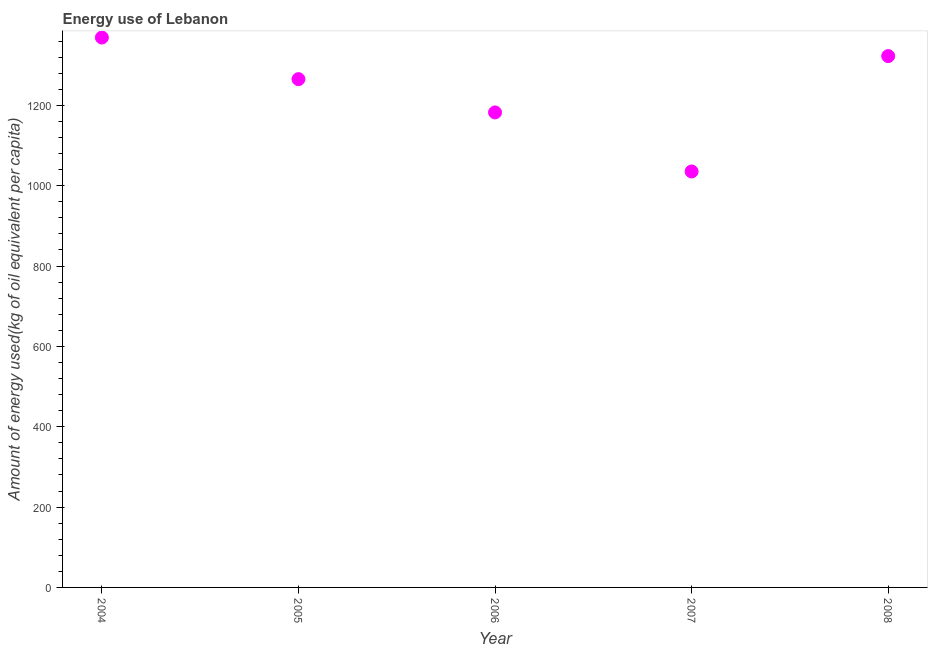What is the amount of energy used in 2007?
Give a very brief answer. 1035.39. Across all years, what is the maximum amount of energy used?
Keep it short and to the point. 1368.81. Across all years, what is the minimum amount of energy used?
Keep it short and to the point. 1035.39. What is the sum of the amount of energy used?
Ensure brevity in your answer.  6174.39. What is the difference between the amount of energy used in 2004 and 2005?
Provide a succinct answer. 103.59. What is the average amount of energy used per year?
Your answer should be very brief. 1234.88. What is the median amount of energy used?
Ensure brevity in your answer.  1265.23. What is the ratio of the amount of energy used in 2007 to that in 2008?
Your response must be concise. 0.78. What is the difference between the highest and the second highest amount of energy used?
Make the answer very short. 46.21. What is the difference between the highest and the lowest amount of energy used?
Provide a succinct answer. 333.42. In how many years, is the amount of energy used greater than the average amount of energy used taken over all years?
Ensure brevity in your answer.  3. How many dotlines are there?
Ensure brevity in your answer.  1. How many years are there in the graph?
Keep it short and to the point. 5. Are the values on the major ticks of Y-axis written in scientific E-notation?
Keep it short and to the point. No. Does the graph contain grids?
Provide a short and direct response. No. What is the title of the graph?
Your answer should be very brief. Energy use of Lebanon. What is the label or title of the Y-axis?
Provide a short and direct response. Amount of energy used(kg of oil equivalent per capita). What is the Amount of energy used(kg of oil equivalent per capita) in 2004?
Keep it short and to the point. 1368.81. What is the Amount of energy used(kg of oil equivalent per capita) in 2005?
Offer a very short reply. 1265.23. What is the Amount of energy used(kg of oil equivalent per capita) in 2006?
Offer a terse response. 1182.36. What is the Amount of energy used(kg of oil equivalent per capita) in 2007?
Ensure brevity in your answer.  1035.39. What is the Amount of energy used(kg of oil equivalent per capita) in 2008?
Your answer should be very brief. 1322.6. What is the difference between the Amount of energy used(kg of oil equivalent per capita) in 2004 and 2005?
Offer a terse response. 103.59. What is the difference between the Amount of energy used(kg of oil equivalent per capita) in 2004 and 2006?
Keep it short and to the point. 186.45. What is the difference between the Amount of energy used(kg of oil equivalent per capita) in 2004 and 2007?
Offer a very short reply. 333.42. What is the difference between the Amount of energy used(kg of oil equivalent per capita) in 2004 and 2008?
Offer a terse response. 46.21. What is the difference between the Amount of energy used(kg of oil equivalent per capita) in 2005 and 2006?
Provide a succinct answer. 82.86. What is the difference between the Amount of energy used(kg of oil equivalent per capita) in 2005 and 2007?
Offer a very short reply. 229.83. What is the difference between the Amount of energy used(kg of oil equivalent per capita) in 2005 and 2008?
Offer a very short reply. -57.38. What is the difference between the Amount of energy used(kg of oil equivalent per capita) in 2006 and 2007?
Your answer should be compact. 146.97. What is the difference between the Amount of energy used(kg of oil equivalent per capita) in 2006 and 2008?
Keep it short and to the point. -140.24. What is the difference between the Amount of energy used(kg of oil equivalent per capita) in 2007 and 2008?
Offer a terse response. -287.21. What is the ratio of the Amount of energy used(kg of oil equivalent per capita) in 2004 to that in 2005?
Give a very brief answer. 1.08. What is the ratio of the Amount of energy used(kg of oil equivalent per capita) in 2004 to that in 2006?
Give a very brief answer. 1.16. What is the ratio of the Amount of energy used(kg of oil equivalent per capita) in 2004 to that in 2007?
Offer a terse response. 1.32. What is the ratio of the Amount of energy used(kg of oil equivalent per capita) in 2004 to that in 2008?
Keep it short and to the point. 1.03. What is the ratio of the Amount of energy used(kg of oil equivalent per capita) in 2005 to that in 2006?
Offer a terse response. 1.07. What is the ratio of the Amount of energy used(kg of oil equivalent per capita) in 2005 to that in 2007?
Offer a terse response. 1.22. What is the ratio of the Amount of energy used(kg of oil equivalent per capita) in 2005 to that in 2008?
Give a very brief answer. 0.96. What is the ratio of the Amount of energy used(kg of oil equivalent per capita) in 2006 to that in 2007?
Provide a succinct answer. 1.14. What is the ratio of the Amount of energy used(kg of oil equivalent per capita) in 2006 to that in 2008?
Keep it short and to the point. 0.89. What is the ratio of the Amount of energy used(kg of oil equivalent per capita) in 2007 to that in 2008?
Make the answer very short. 0.78. 